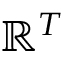Convert formula to latex. <formula><loc_0><loc_0><loc_500><loc_500>\mathbb { R } ^ { T }</formula> 